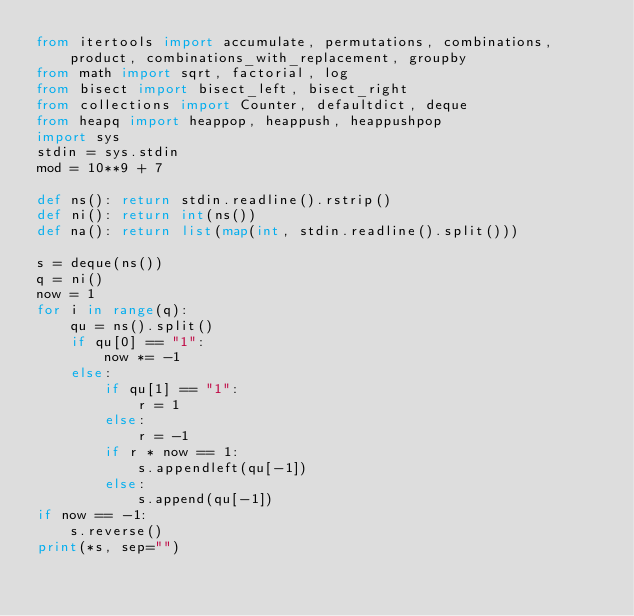<code> <loc_0><loc_0><loc_500><loc_500><_Python_>from itertools import accumulate, permutations, combinations, product, combinations_with_replacement, groupby
from math import sqrt, factorial, log
from bisect import bisect_left, bisect_right
from collections import Counter, defaultdict, deque
from heapq import heappop, heappush, heappushpop
import sys
stdin = sys.stdin
mod = 10**9 + 7

def ns(): return stdin.readline().rstrip()
def ni(): return int(ns())
def na(): return list(map(int, stdin.readline().split()))

s = deque(ns())
q = ni()
now = 1
for i in range(q):
    qu = ns().split()
    if qu[0] == "1":
        now *= -1
    else:
        if qu[1] == "1":
            r = 1
        else:
            r = -1
        if r * now == 1:
            s.appendleft(qu[-1])
        else:
            s.append(qu[-1])
if now == -1:
    s.reverse()
print(*s, sep="")</code> 